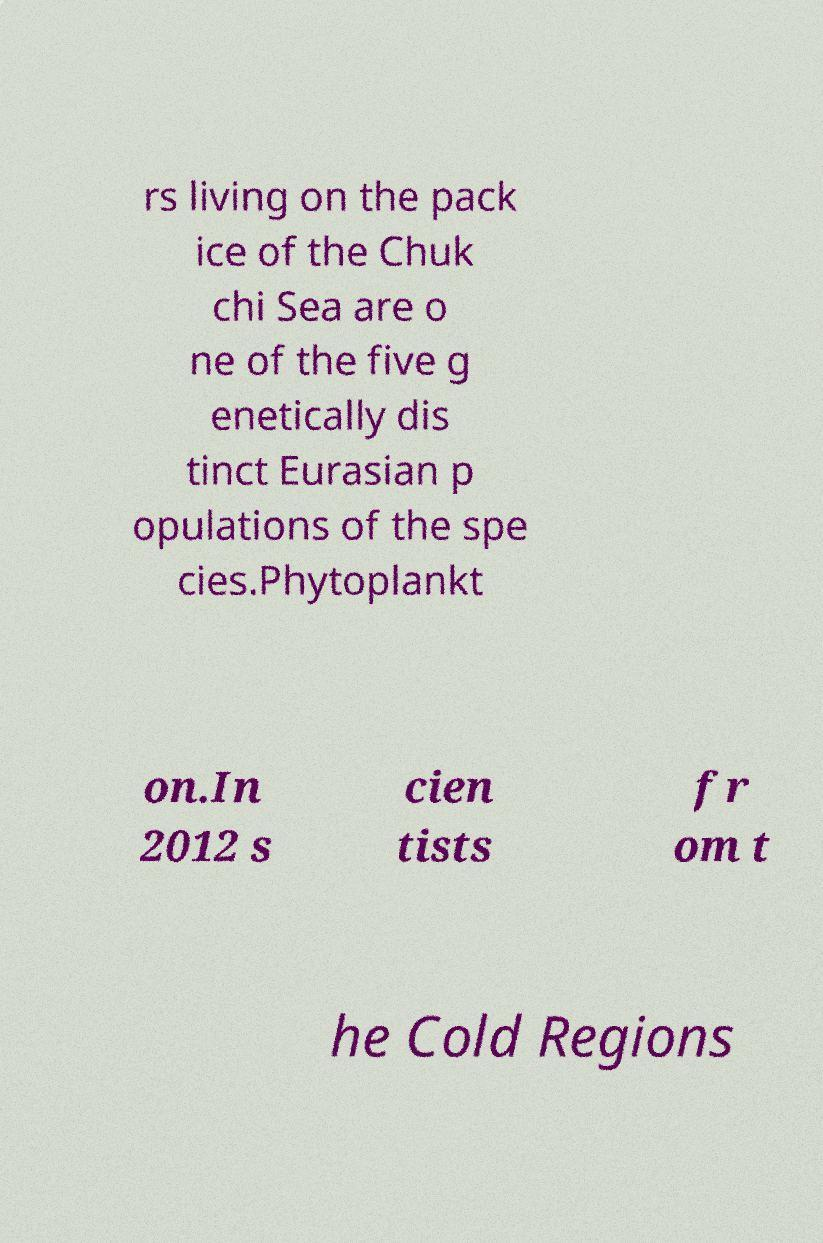Can you read and provide the text displayed in the image?This photo seems to have some interesting text. Can you extract and type it out for me? rs living on the pack ice of the Chuk chi Sea are o ne of the five g enetically dis tinct Eurasian p opulations of the spe cies.Phytoplankt on.In 2012 s cien tists fr om t he Cold Regions 